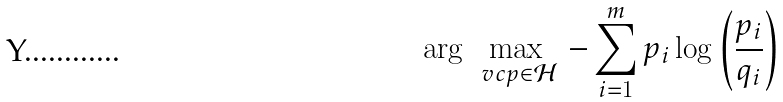<formula> <loc_0><loc_0><loc_500><loc_500>\arg \, \max _ { \ v c p \in \mathcal { H } } \, - \sum _ { i = 1 } ^ { m } p _ { i } \log \left ( \frac { p _ { i } } { q _ { i } } \right )</formula> 